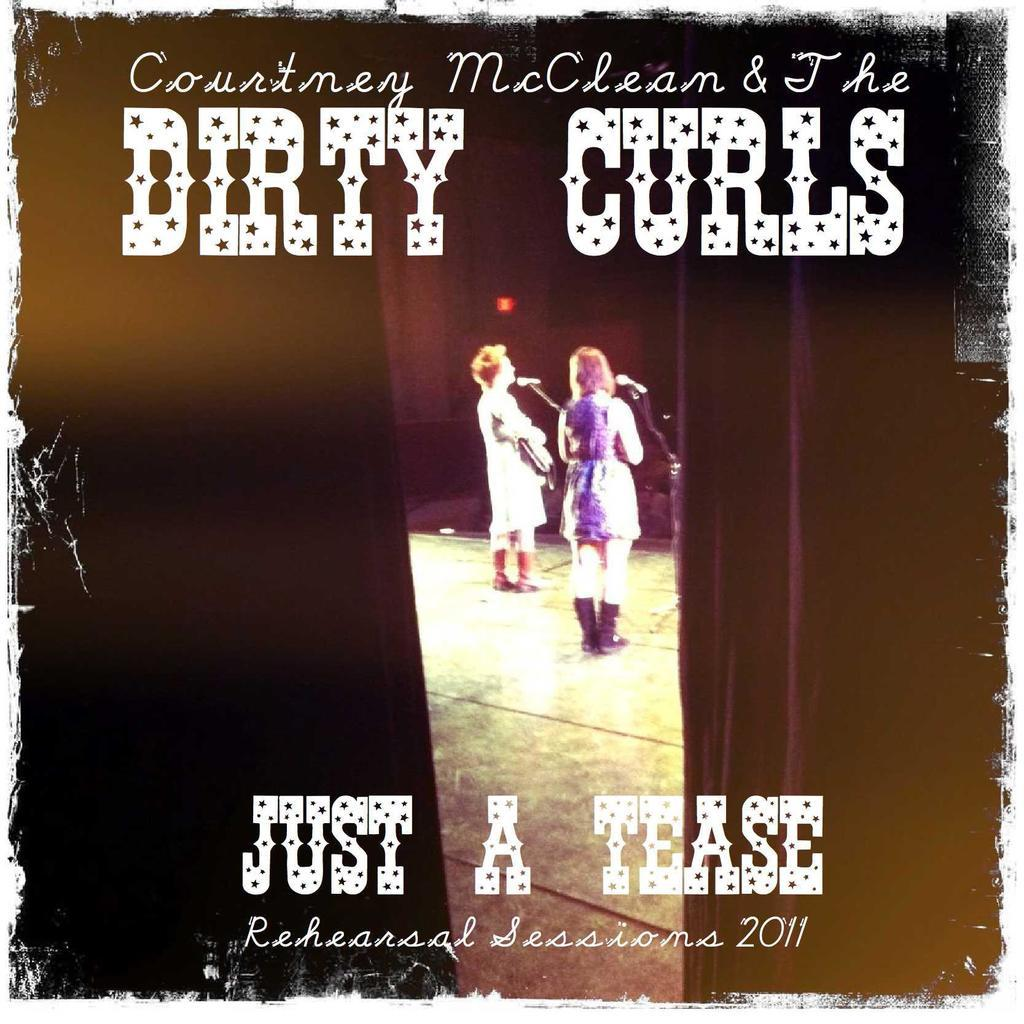<image>
Present a compact description of the photo's key features. Album cover showing two women performing titled "Just A Tease". 